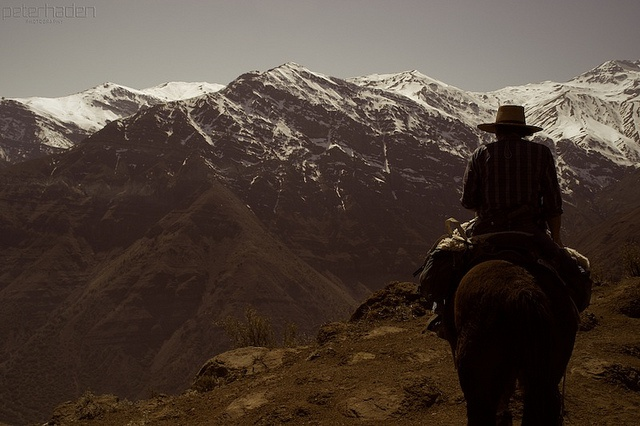Describe the objects in this image and their specific colors. I can see people in gray, black, and maroon tones and horse in black, maroon, and gray tones in this image. 